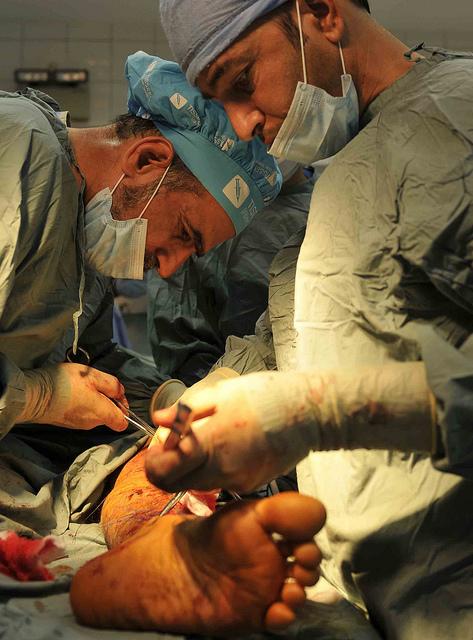What body part of the patient is shown?
Write a very short answer. Foot. Is the Dr performing surgery?
Write a very short answer. Yes. Would you trust this doctor?
Concise answer only. Yes. 